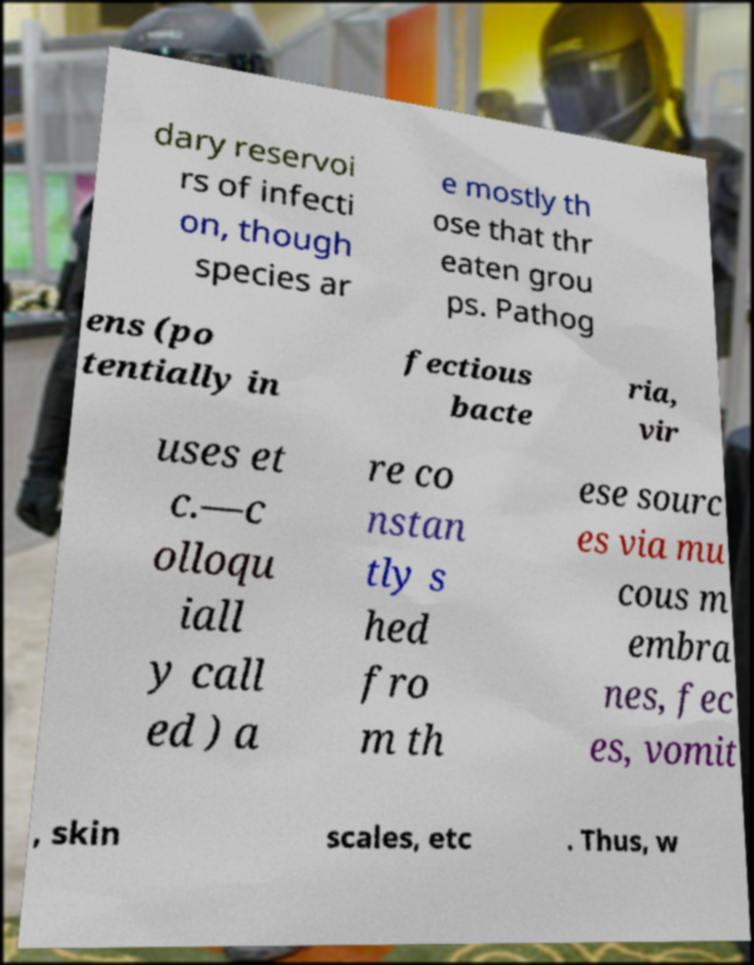For documentation purposes, I need the text within this image transcribed. Could you provide that? dary reservoi rs of infecti on, though species ar e mostly th ose that thr eaten grou ps. Pathog ens (po tentially in fectious bacte ria, vir uses et c.—c olloqu iall y call ed ) a re co nstan tly s hed fro m th ese sourc es via mu cous m embra nes, fec es, vomit , skin scales, etc . Thus, w 